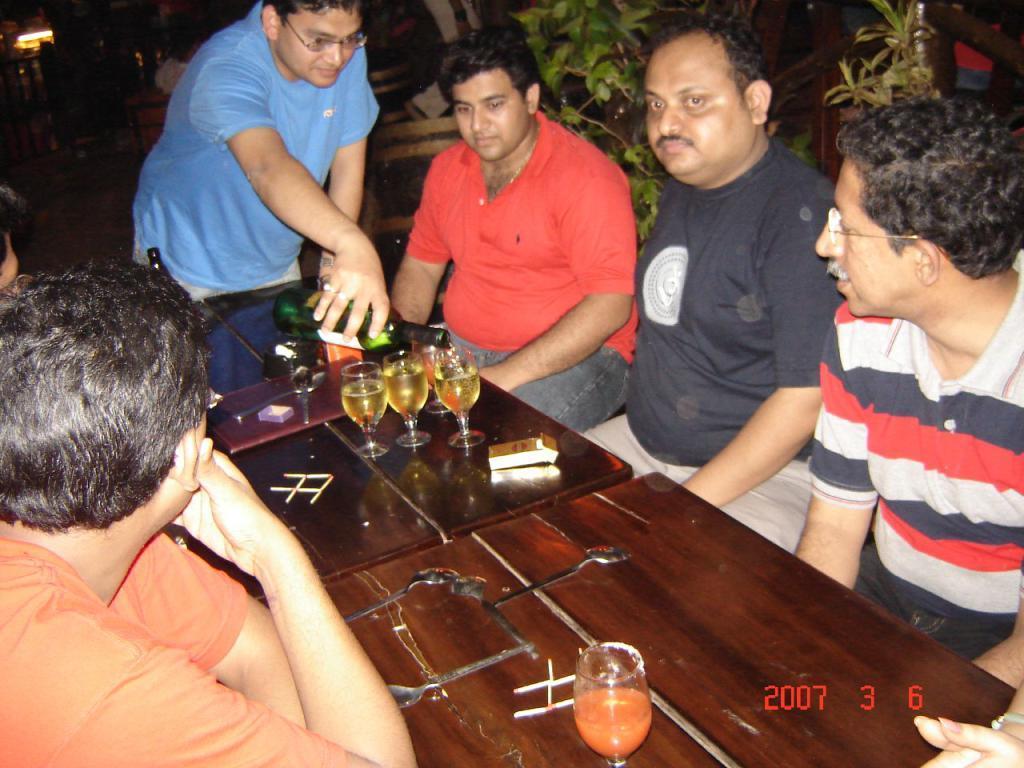Please provide a concise description of this image. In this picture we can see some people sitting on the chairs in front of the tables on which there are some glasses, a cigar box, matchsticks and a person standing and some plants around them. 